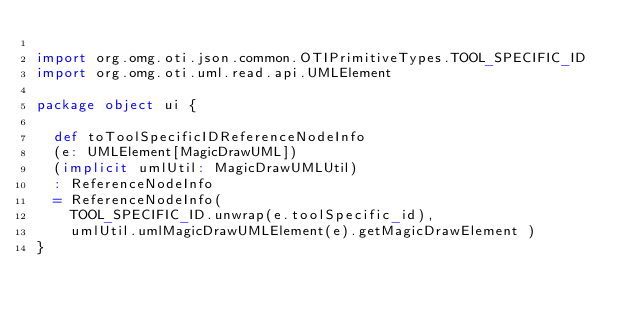<code> <loc_0><loc_0><loc_500><loc_500><_Scala_>
import org.omg.oti.json.common.OTIPrimitiveTypes.TOOL_SPECIFIC_ID
import org.omg.oti.uml.read.api.UMLElement

package object ui {

  def toToolSpecificIDReferenceNodeInfo
  (e: UMLElement[MagicDrawUML])
  (implicit umlUtil: MagicDrawUMLUtil)
  : ReferenceNodeInfo
  = ReferenceNodeInfo(
    TOOL_SPECIFIC_ID.unwrap(e.toolSpecific_id),
    umlUtil.umlMagicDrawUMLElement(e).getMagicDrawElement )
}</code> 